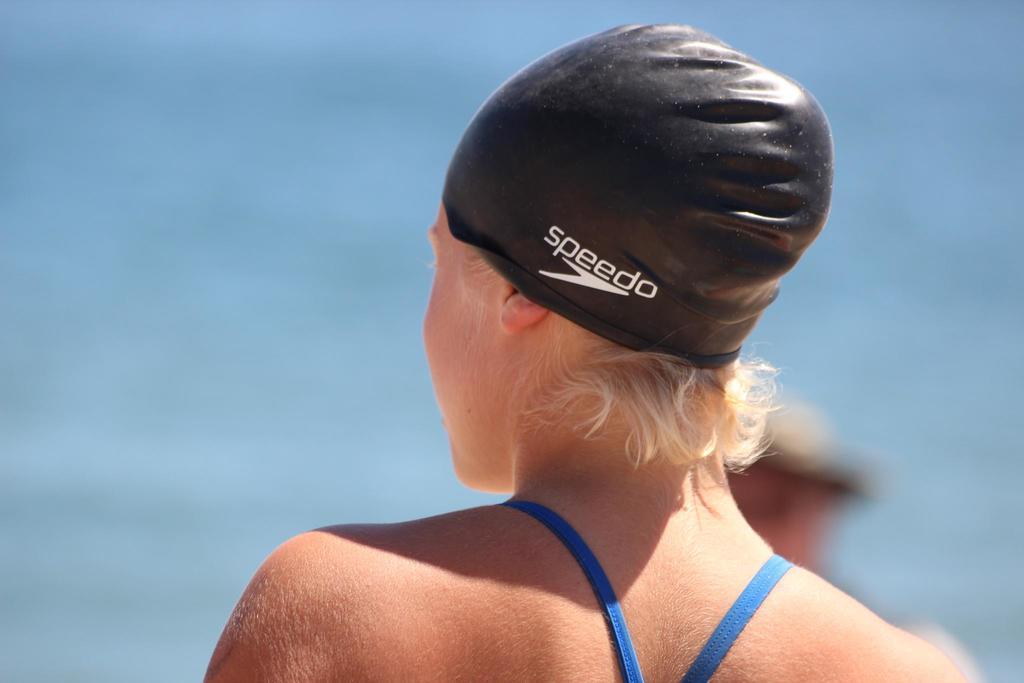Please provide a concise description of this image. In this image there is a person with a swimming cap , and there is blur background. 